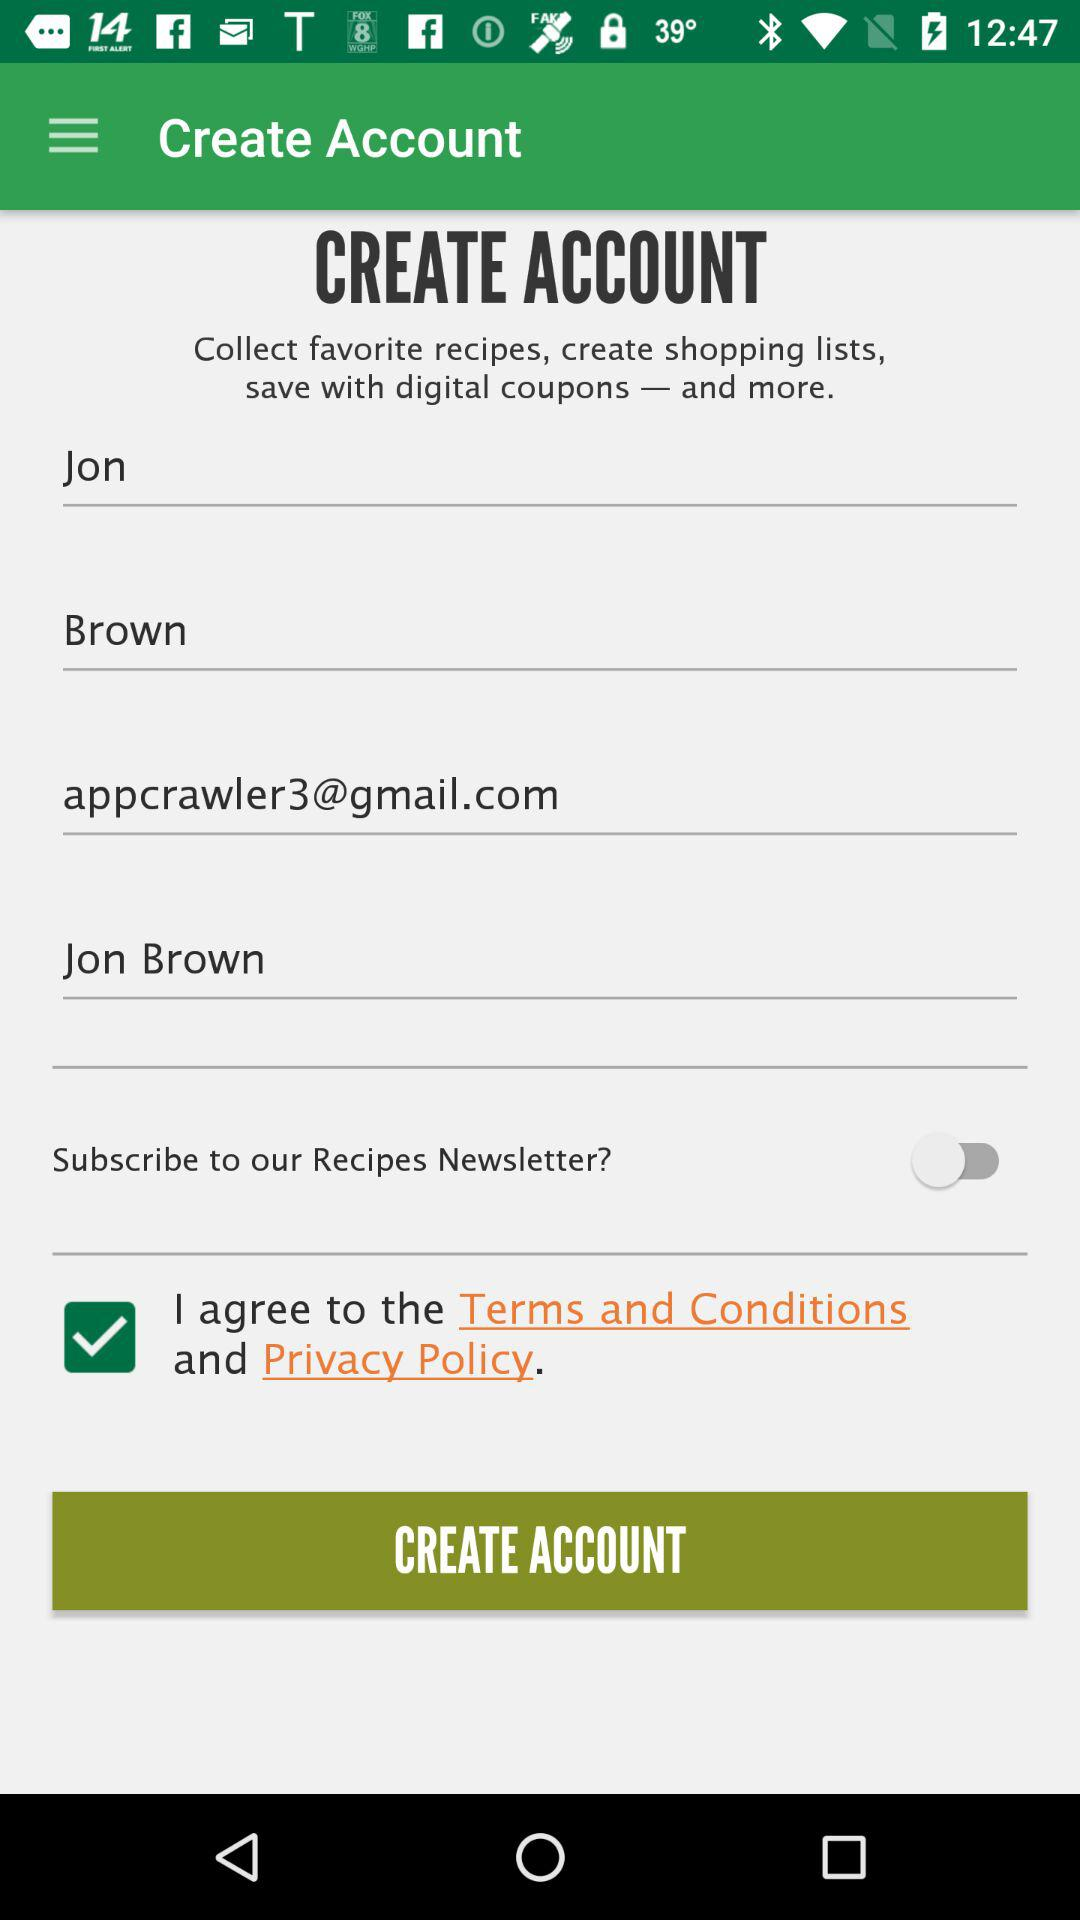What is the name of the person? The name of the person is Jon Brown. 